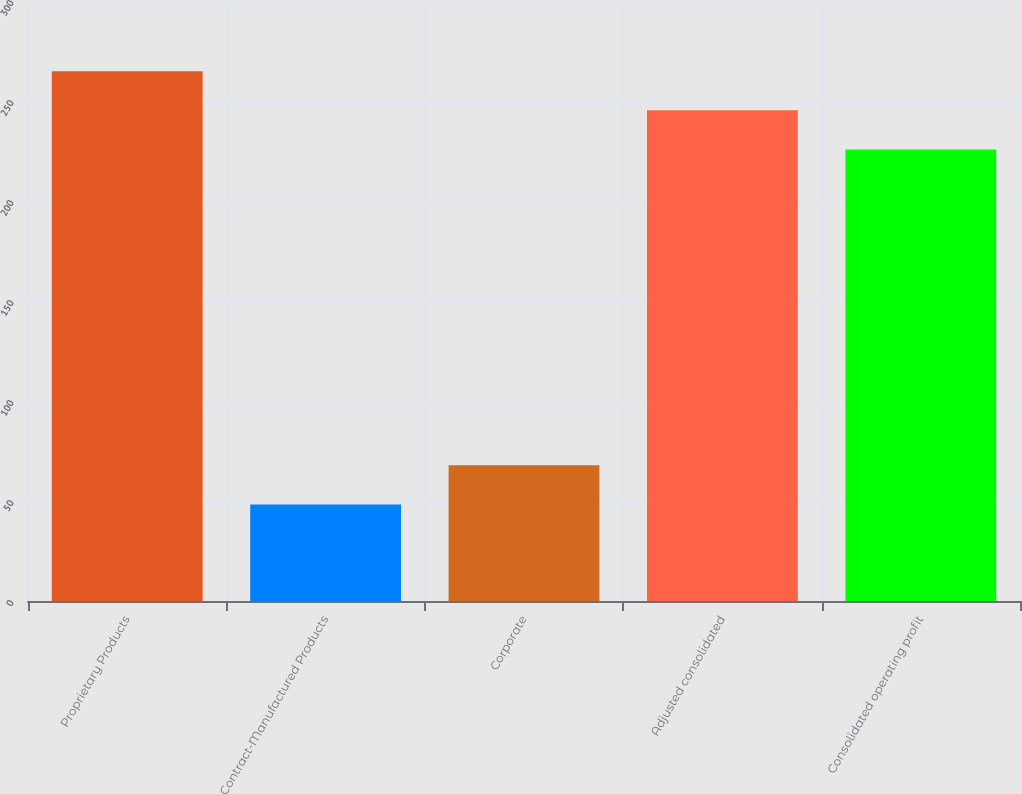Convert chart. <chart><loc_0><loc_0><loc_500><loc_500><bar_chart><fcel>Proprietary Products<fcel>Contract-Manufactured Products<fcel>Corporate<fcel>Adjusted consolidated<fcel>Consolidated operating profit<nl><fcel>264.9<fcel>48.3<fcel>67.85<fcel>245.35<fcel>225.8<nl></chart> 